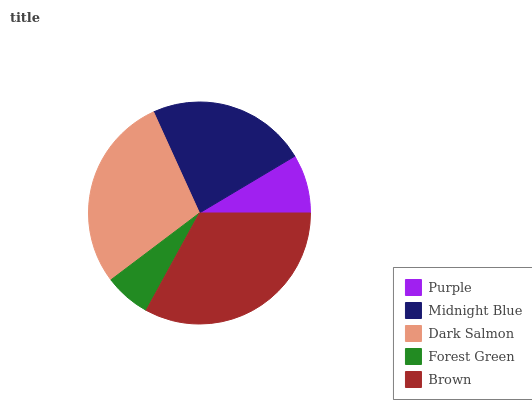Is Forest Green the minimum?
Answer yes or no. Yes. Is Brown the maximum?
Answer yes or no. Yes. Is Midnight Blue the minimum?
Answer yes or no. No. Is Midnight Blue the maximum?
Answer yes or no. No. Is Midnight Blue greater than Purple?
Answer yes or no. Yes. Is Purple less than Midnight Blue?
Answer yes or no. Yes. Is Purple greater than Midnight Blue?
Answer yes or no. No. Is Midnight Blue less than Purple?
Answer yes or no. No. Is Midnight Blue the high median?
Answer yes or no. Yes. Is Midnight Blue the low median?
Answer yes or no. Yes. Is Forest Green the high median?
Answer yes or no. No. Is Brown the low median?
Answer yes or no. No. 